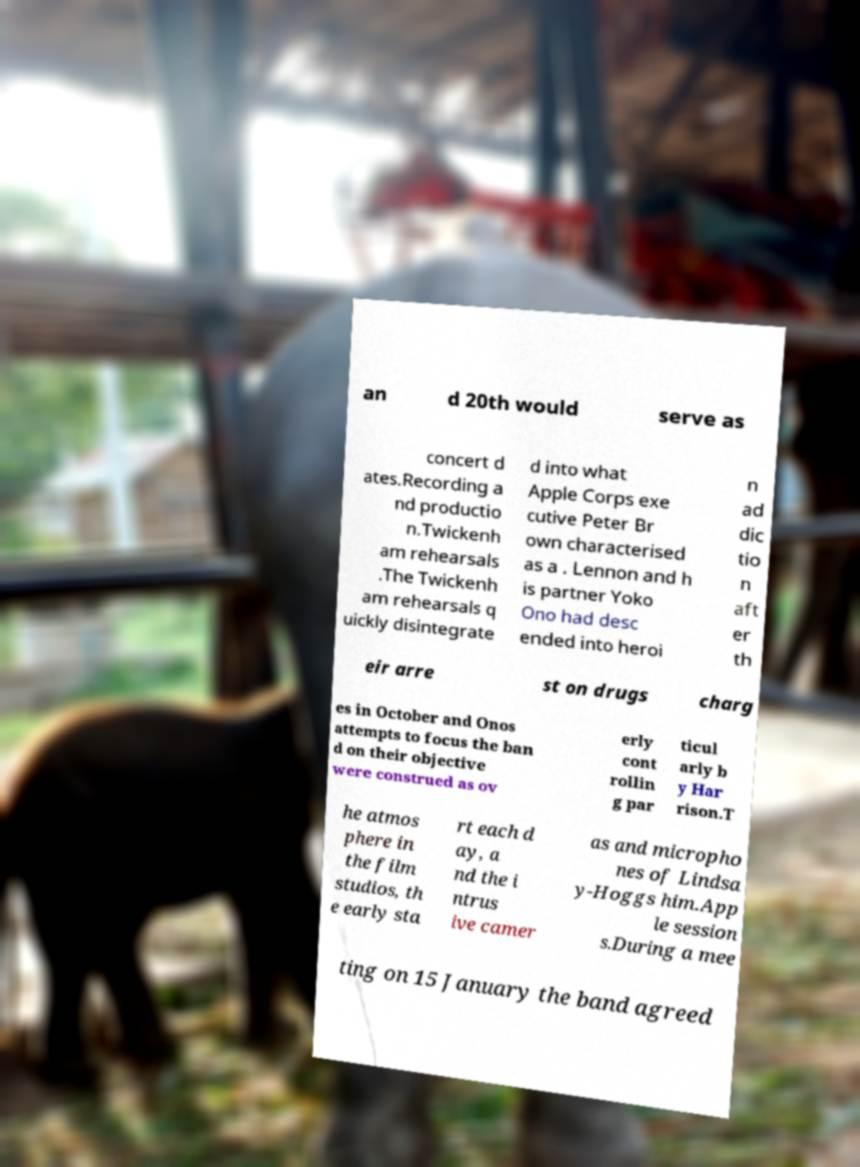I need the written content from this picture converted into text. Can you do that? an d 20th would serve as concert d ates.Recording a nd productio n.Twickenh am rehearsals .The Twickenh am rehearsals q uickly disintegrate d into what Apple Corps exe cutive Peter Br own characterised as a . Lennon and h is partner Yoko Ono had desc ended into heroi n ad dic tio n aft er th eir arre st on drugs charg es in October and Onos attempts to focus the ban d on their objective were construed as ov erly cont rollin g par ticul arly b y Har rison.T he atmos phere in the film studios, th e early sta rt each d ay, a nd the i ntrus ive camer as and micropho nes of Lindsa y-Hoggs him.App le session s.During a mee ting on 15 January the band agreed 